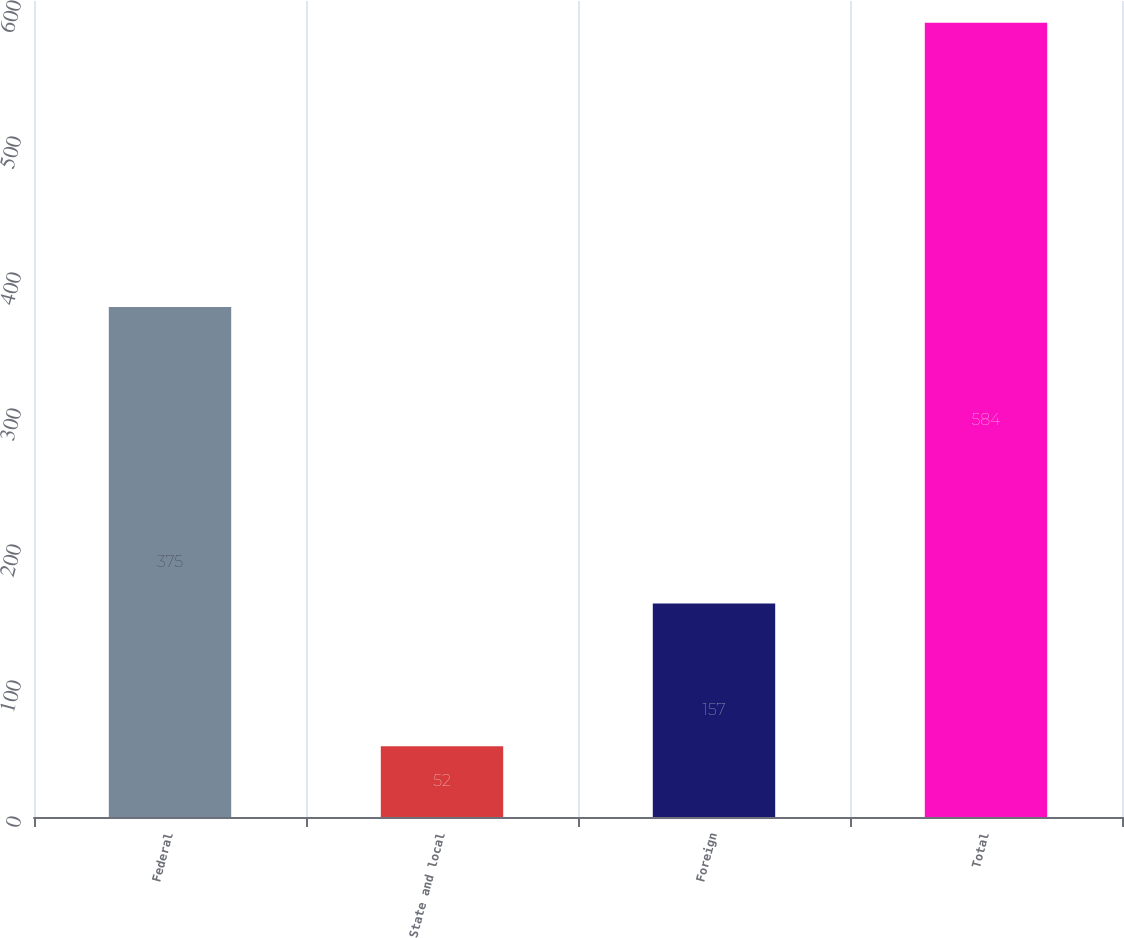<chart> <loc_0><loc_0><loc_500><loc_500><bar_chart><fcel>Federal<fcel>State and local<fcel>Foreign<fcel>Total<nl><fcel>375<fcel>52<fcel>157<fcel>584<nl></chart> 